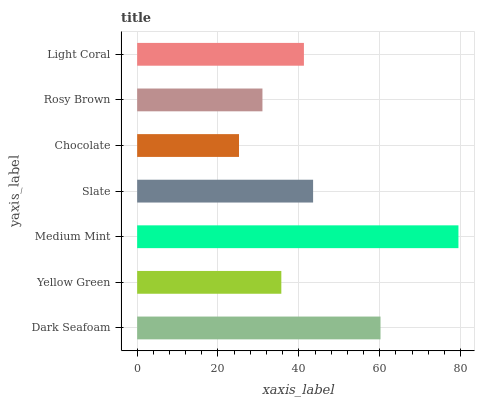Is Chocolate the minimum?
Answer yes or no. Yes. Is Medium Mint the maximum?
Answer yes or no. Yes. Is Yellow Green the minimum?
Answer yes or no. No. Is Yellow Green the maximum?
Answer yes or no. No. Is Dark Seafoam greater than Yellow Green?
Answer yes or no. Yes. Is Yellow Green less than Dark Seafoam?
Answer yes or no. Yes. Is Yellow Green greater than Dark Seafoam?
Answer yes or no. No. Is Dark Seafoam less than Yellow Green?
Answer yes or no. No. Is Light Coral the high median?
Answer yes or no. Yes. Is Light Coral the low median?
Answer yes or no. Yes. Is Slate the high median?
Answer yes or no. No. Is Slate the low median?
Answer yes or no. No. 